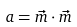Convert formula to latex. <formula><loc_0><loc_0><loc_500><loc_500>a = \vec { m } \cdot \vec { m }</formula> 